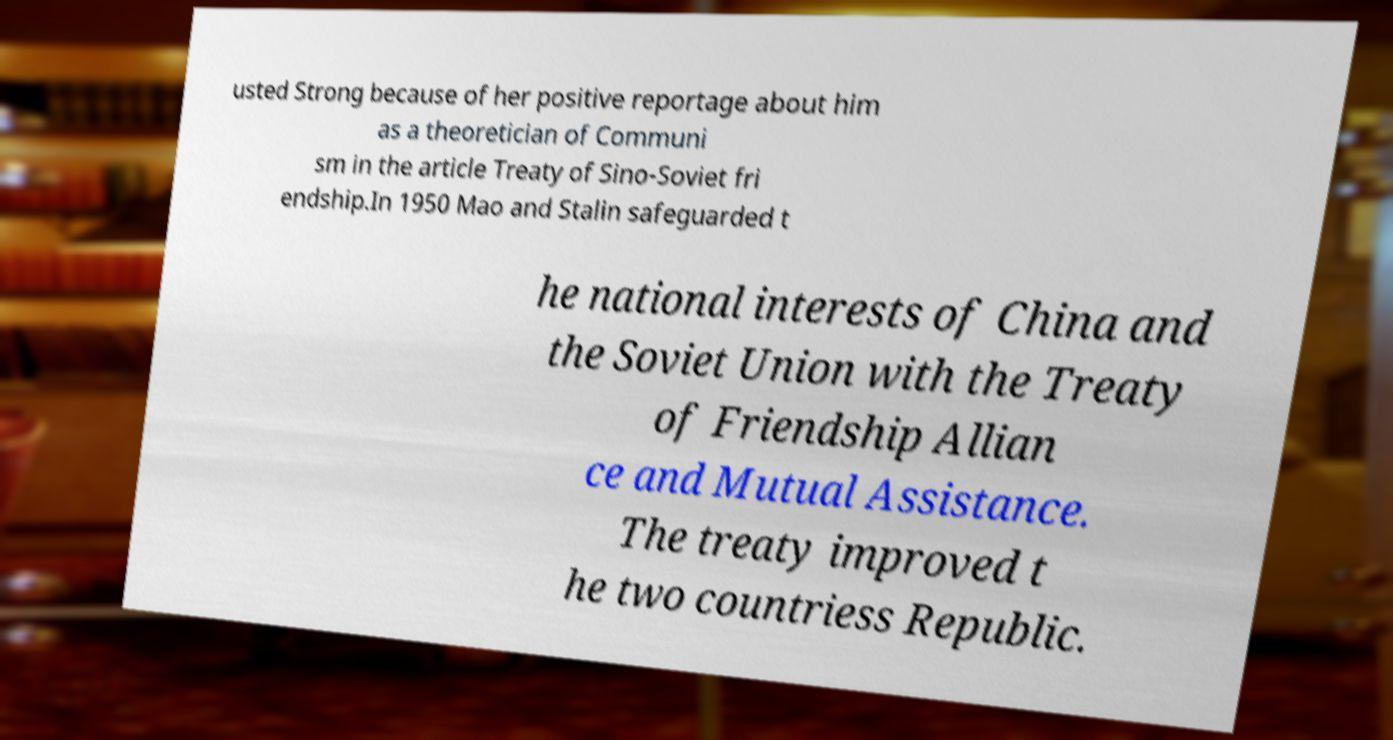Can you accurately transcribe the text from the provided image for me? usted Strong because of her positive reportage about him as a theoretician of Communi sm in the article Treaty of Sino-Soviet fri endship.In 1950 Mao and Stalin safeguarded t he national interests of China and the Soviet Union with the Treaty of Friendship Allian ce and Mutual Assistance. The treaty improved t he two countriess Republic. 